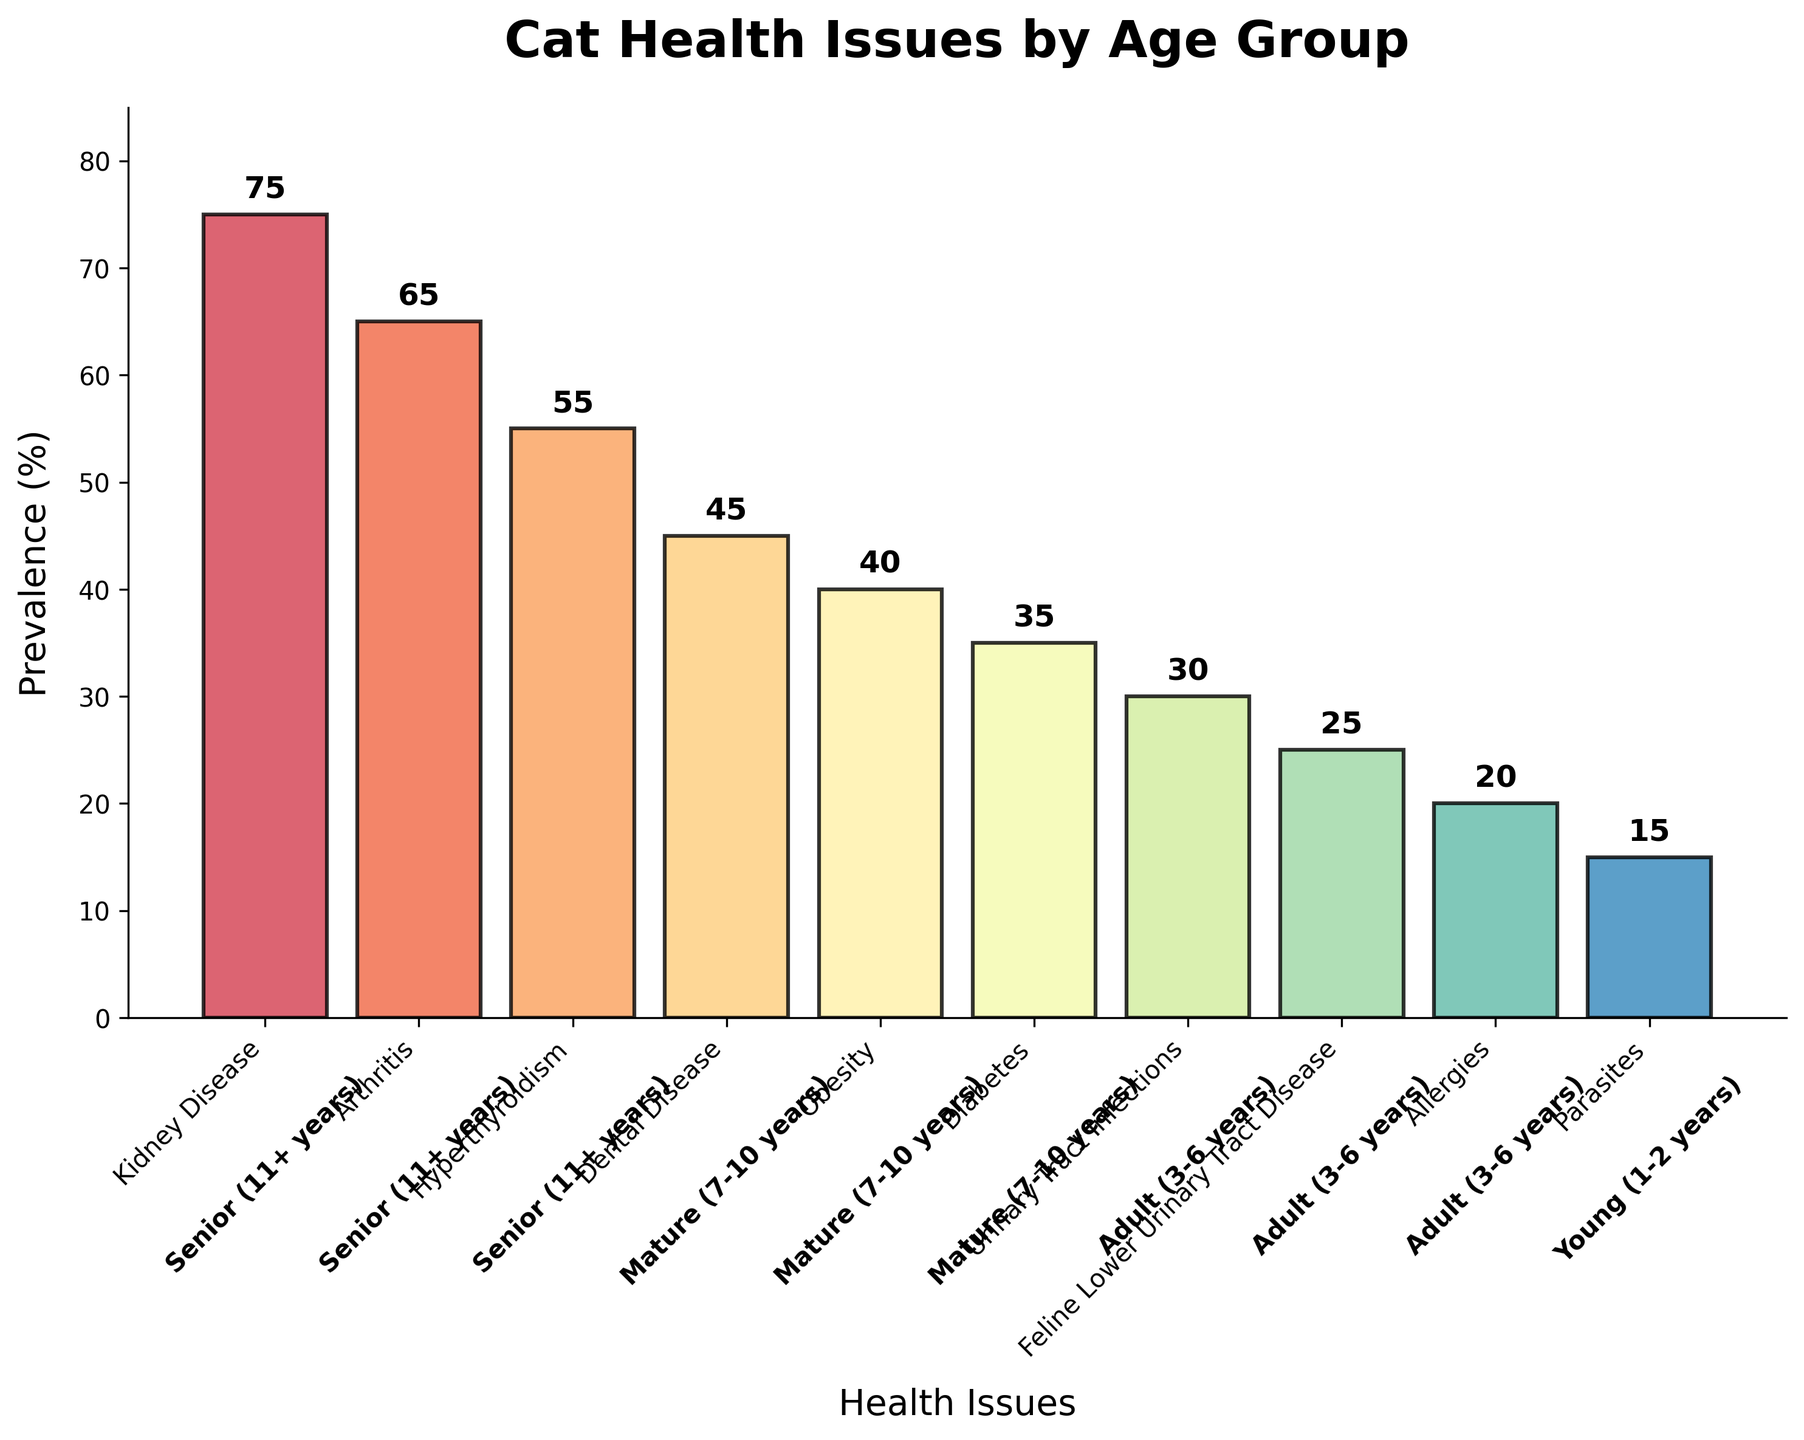What is the most common health issue among senior cats (11+ years)? Look at the bar with the highest prevalence in the age group "Senior (11+ years)." The highest bar corresponds to "Kidney Disease."
Answer: Kidney Disease Which health issue has the highest overall prevalence in cats? Identify the bar with the highest value on the y-axis. Kidney Disease has the highest prevalence at 75%.
Answer: Kidney Disease What is the prevalence of obesity in mature cats (7-10 years)? Find the bar labeled "Obesity" and note its height corresponding to the prevalence value. The prevalence is marked as 40%.
Answer: 40% How does the prevalence of diabetes in mature cats (7-10 years) compare to hyperthyroidism in senior cats (11+ years)? Identify the bars for "Diabetes" in mature cats and "Hyperthyroidism" in senior cats. Compare their heights. Diabetes has a prevalence of 35%, while Hyperthyroidism has 55%. Hyperthyroidism is more prevalent.
Answer: Hyperthyroidism is more prevalent What is the total prevalence of health issues in adult cats (3-6 years)? Locate all bars corresponding to the "Adult (3-6 years)" age group and sum their values: Urinary Tract Infections (30%), Feline Lower Urinary Tract Disease (25%), and Allergies (20%). The total is 30 + 25 + 20 = 75%.
Answer: 75% Which health issue has the lowest prevalence, and what is the age group for this issue? Find the bar with the smallest height. "Parasites" have the lowest prevalence (15%) and belong to the "Young (1-2 years)" age group.
Answer: Parasites, Young (1-2 years) If you sum the prevalence of kidney disease and dental disease, what would be the total percentage? Add the prevalence of Kidney Disease (75%) and Dental Disease (45%). The total is 75 + 45 = 120%.
Answer: 120% How much more prevalent is arthritis in senior cats compared to diabetes in mature cats? Subtract the prevalence of Diabetes (35%) from the prevalence of Arthritis (65%). The difference is 65 - 35 = 30%.
Answer: 30% What is the average prevalence of the three health issues in mature cats (7-10 years)? Add the prevalence values of the three health issues: Dental Disease (45%), Obesity (40%), Diabetes (35%). The sum is 45 + 40 + 35 = 120%. Divide by 3 to get the average: 120 / 3 = 40%.
Answer: 40% Which age group has the most bars representing health issues on the chart? Count the number of bars for each age group: Senior (3 bars), Mature (3 bars), Adult (3 bars), Young (1 bar). The Senior, Mature, and Adult groups each have the most bars (3).
Answer: Senior, Mature, Adult (tie) 